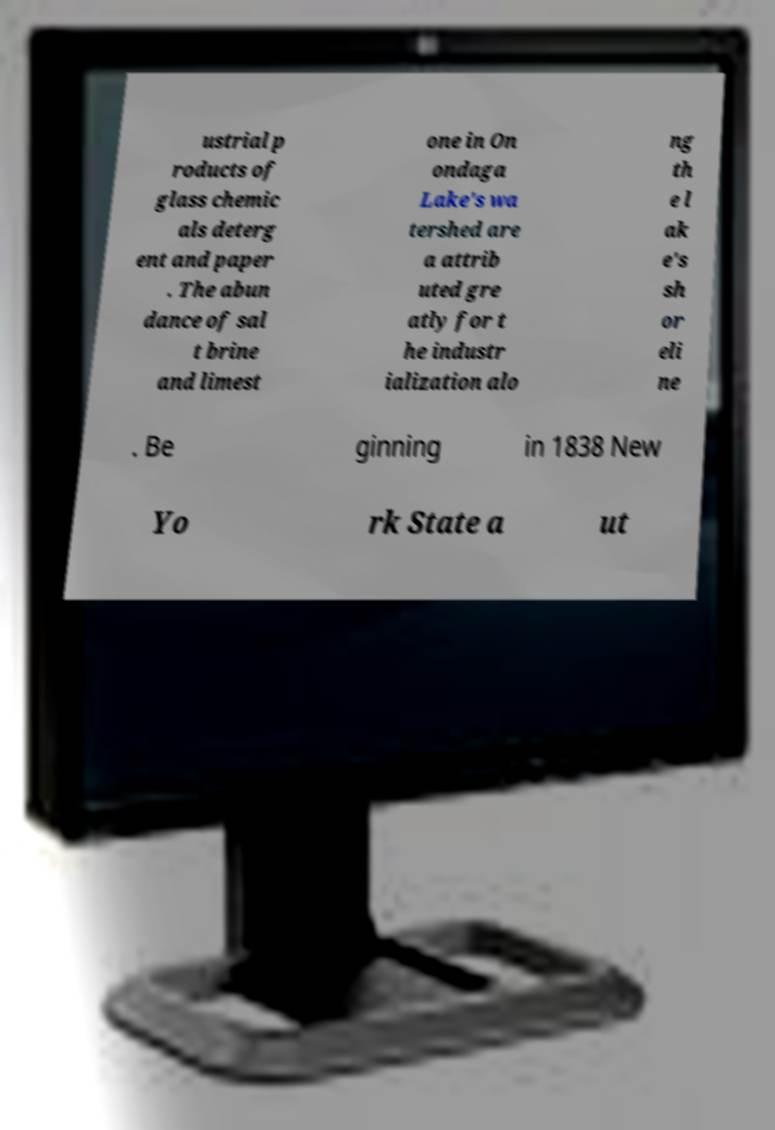Can you read and provide the text displayed in the image?This photo seems to have some interesting text. Can you extract and type it out for me? ustrial p roducts of glass chemic als deterg ent and paper . The abun dance of sal t brine and limest one in On ondaga Lake's wa tershed are a attrib uted gre atly for t he industr ialization alo ng th e l ak e's sh or eli ne . Be ginning in 1838 New Yo rk State a ut 